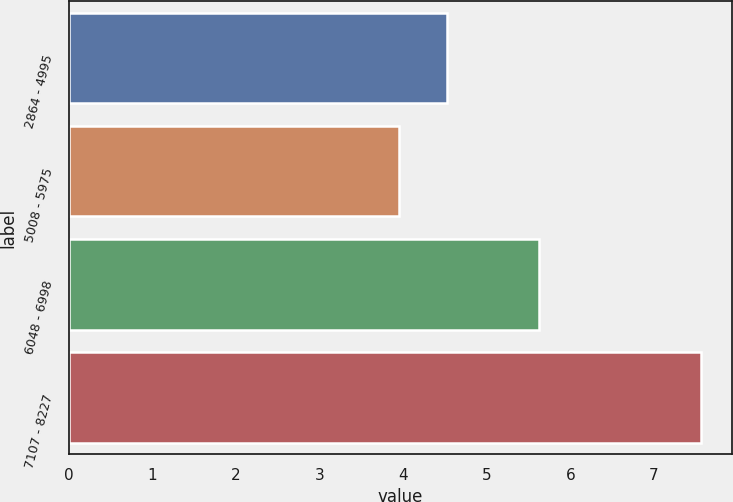Convert chart. <chart><loc_0><loc_0><loc_500><loc_500><bar_chart><fcel>2864 - 4995<fcel>5008 - 5975<fcel>6048 - 6998<fcel>7107 - 8227<nl><fcel>4.53<fcel>3.95<fcel>5.62<fcel>7.56<nl></chart> 